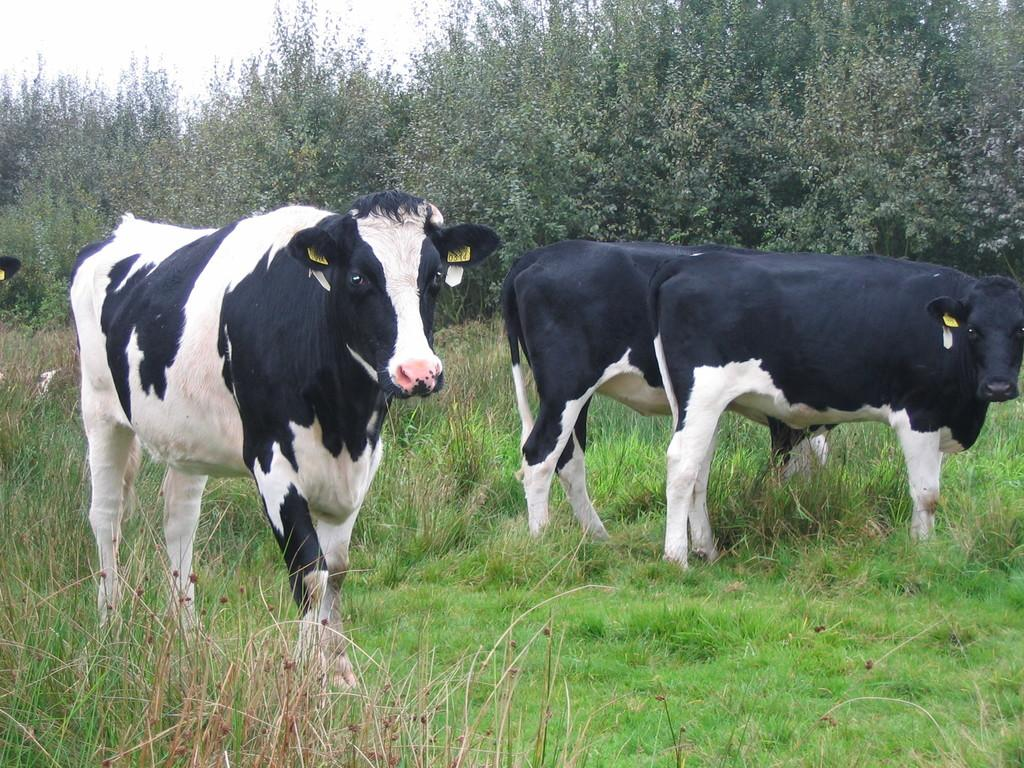What is located in the center of the image? There are animals in the center of the image. What type of vegetation is at the bottom of the image? There is grass and plants at the bottom of the image. What can be seen in the background of the image? There are trees and the sky visible in the background of the image. What type of lumber is being used to build the queen's wheel in the image? There is no lumber, queen, or wheel present in the image. 